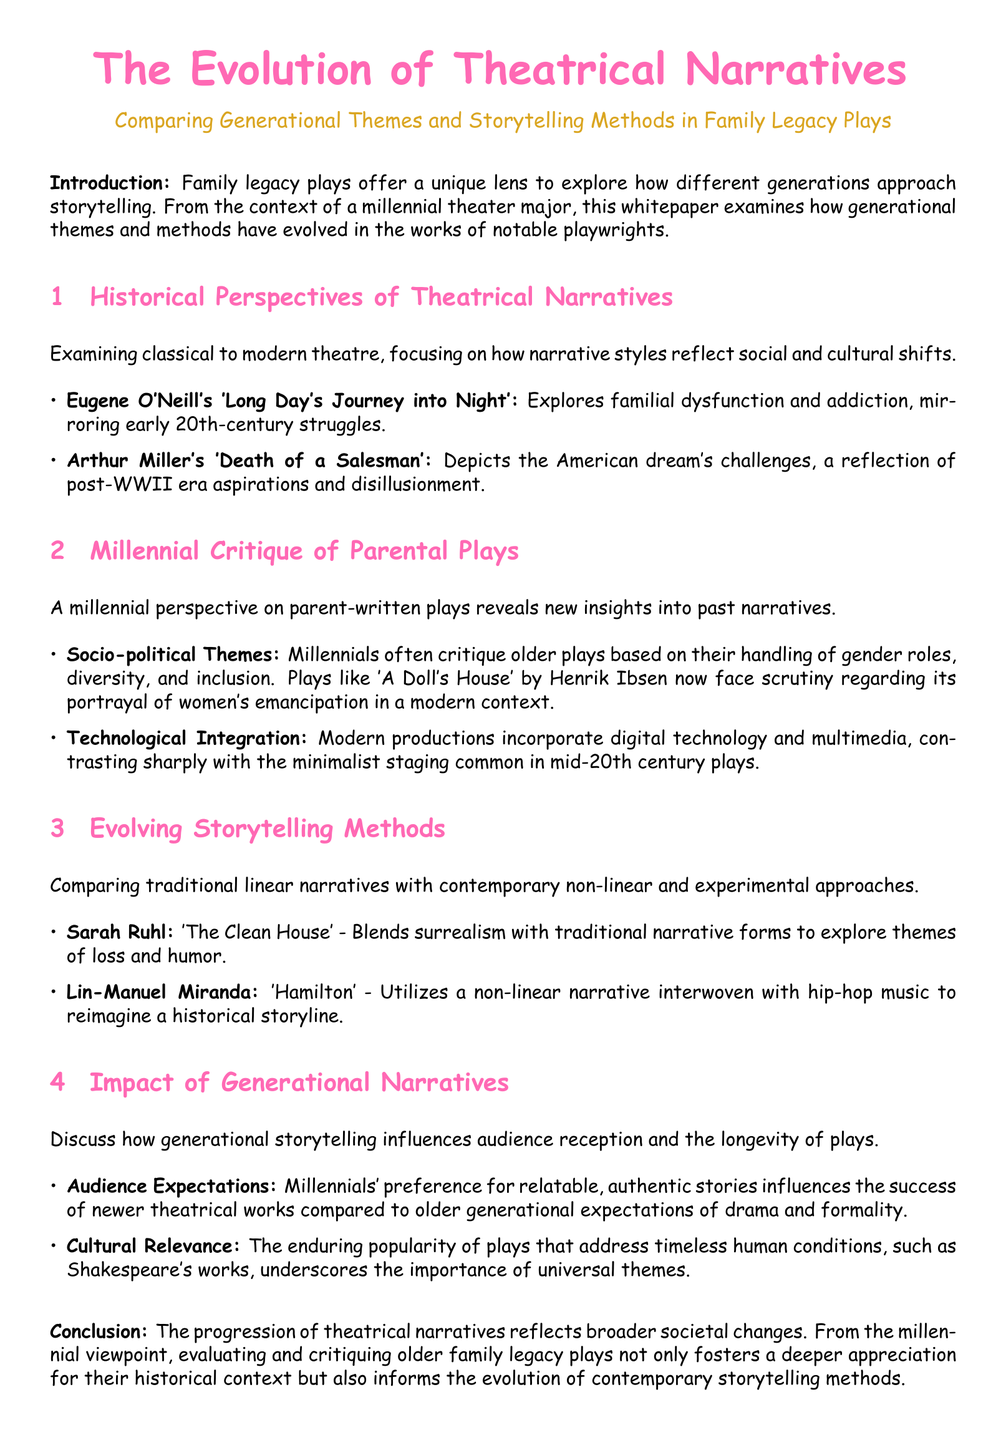What play did Eugene O'Neill write? Eugene O'Neill's play is mentioned as 'Long Day's Journey into Night', which explores familial dysfunction.
Answer: Long Day's Journey into Night What modern playwright uses hip-hop in their narrative? The document mentions Lin-Manuel Miranda's work, which incorporates hip-hop music.
Answer: Hamilton Which playwright is known for 'Death of a Salesman'? Arthur Miller is identified as the playwright of 'Death of a Salesman', which reflects post-WWII aspirations.
Answer: Arthur Miller What is a primary focus of millennial critiques on older plays? The critiques often highlight handling of gender roles, diversity, and inclusion in family legacy plays.
Answer: Socio-political Themes Which storytelling method contrasts with traditional linear narratives? The document discusses contemporary non-linear and experimental approaches as evolving storytelling methods.
Answer: Non-linear How do audience expectations differ between millennials and older generations? Millennials prefer relatable and authentic stories compared to older generational expectations of drama and formality.
Answer: Relatable, authentic stories What color is used for section headings in the document? The color specified for section headings in the document is identified as millennial.
Answer: Millennial What is the purpose of family legacy plays according to the document? Family legacy plays are described as a lens to explore different generations' storytelling approaches.
Answer: Explore storytelling approaches 